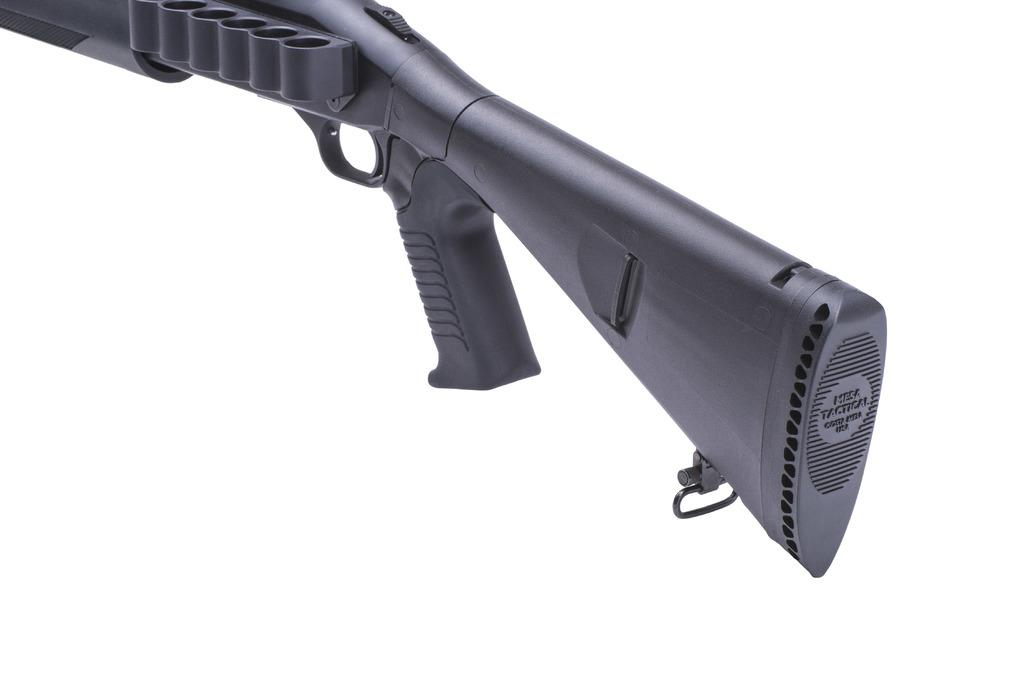What is the main object in the picture? There is a weapon in the picture. What color is the weapon? The weapon is black in color. What type of holiday is being celebrated in the picture? There is no indication of a holiday being celebrated in the picture, as it only features a weapon. What type of railway system is visible in the picture? There is no railway system present in the picture; it only features a weapon. 